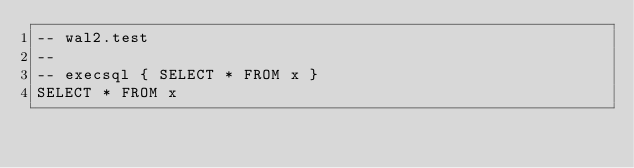Convert code to text. <code><loc_0><loc_0><loc_500><loc_500><_SQL_>-- wal2.test
-- 
-- execsql { SELECT * FROM x }
SELECT * FROM x</code> 